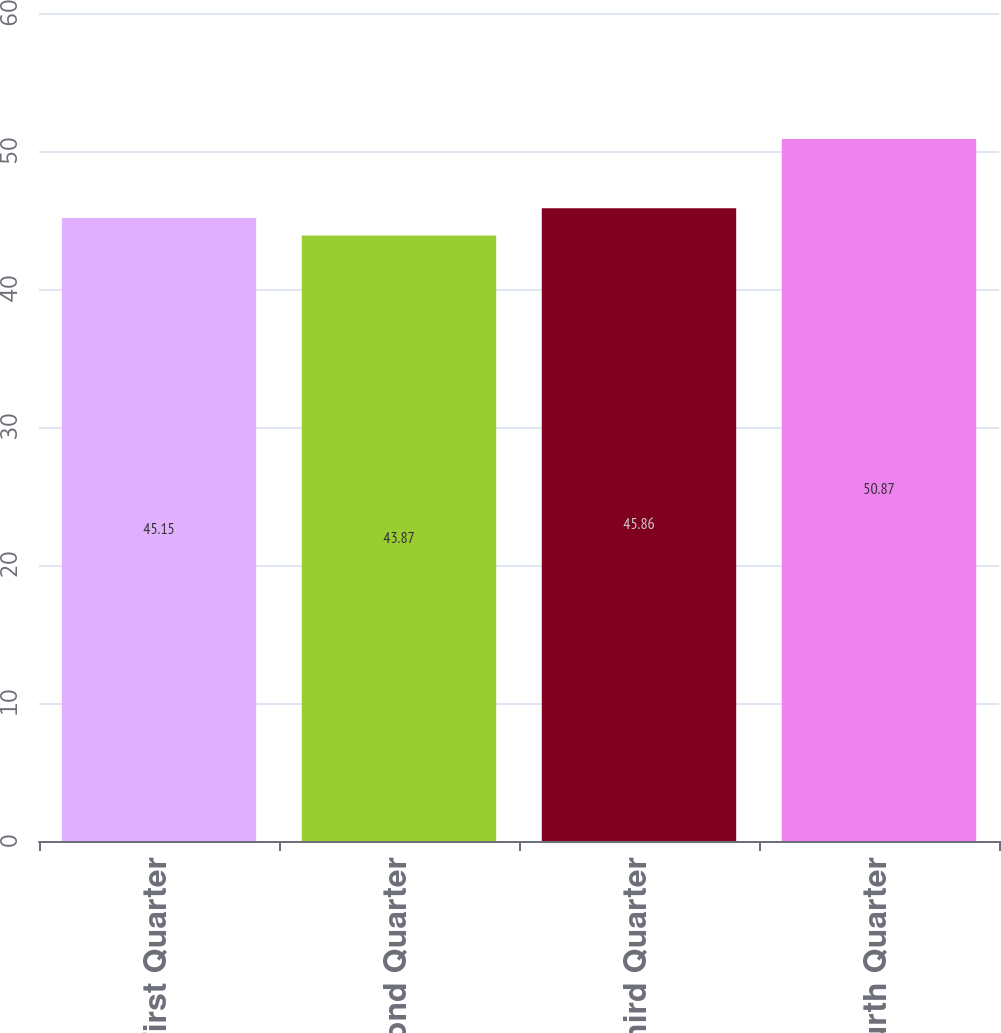<chart> <loc_0><loc_0><loc_500><loc_500><bar_chart><fcel>First Quarter<fcel>Second Quarter<fcel>Third Quarter<fcel>Fourth Quarter<nl><fcel>45.15<fcel>43.87<fcel>45.86<fcel>50.87<nl></chart> 